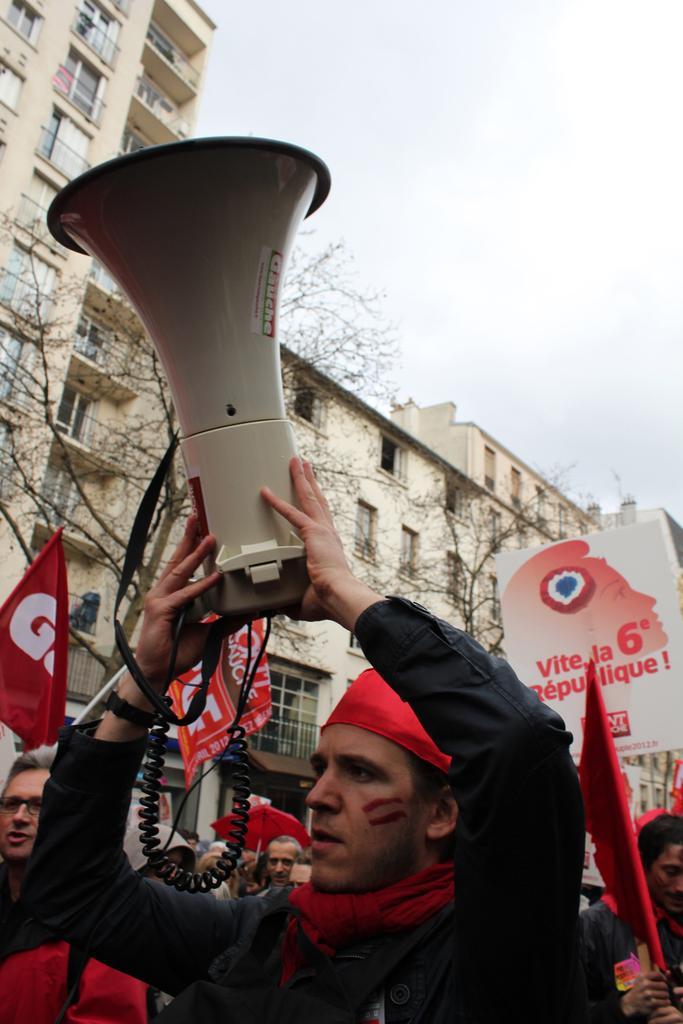Could you give a brief overview of what you see in this image? In this picture we can see a group of people, banners, lights, buildings with windows, trees and in the background we can see the sky. 